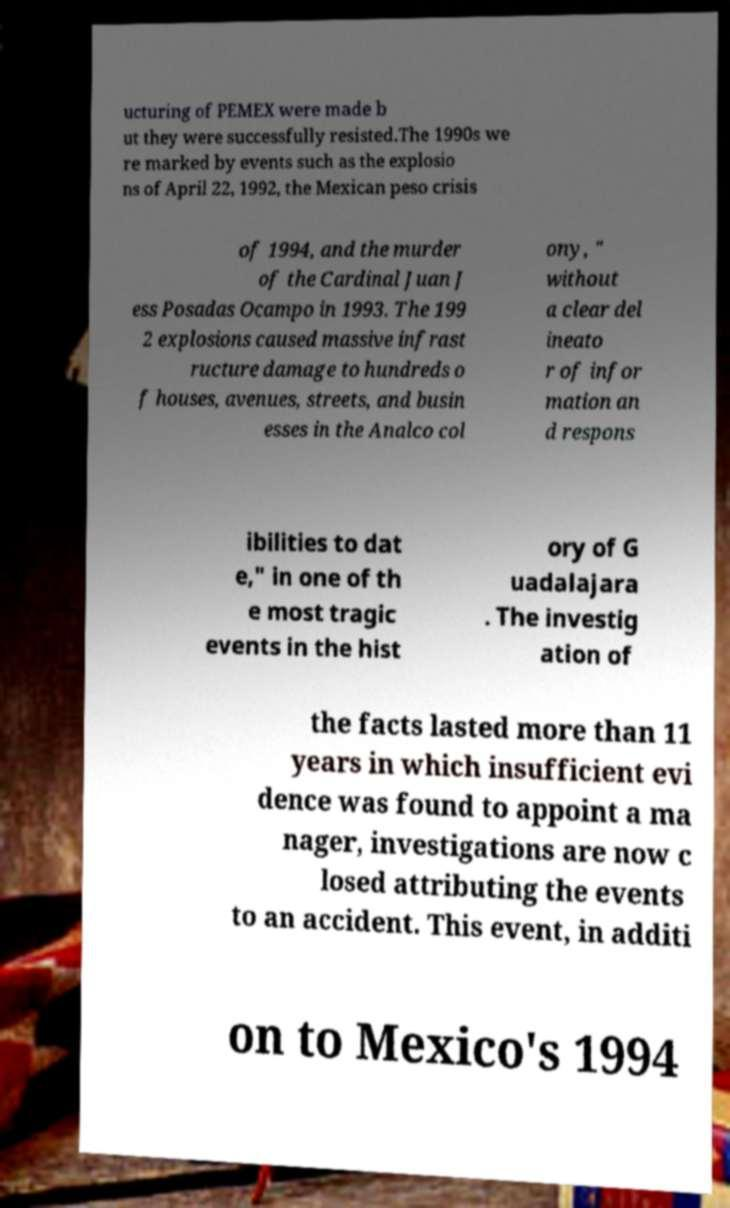There's text embedded in this image that I need extracted. Can you transcribe it verbatim? ucturing of PEMEX were made b ut they were successfully resisted.The 1990s we re marked by events such as the explosio ns of April 22, 1992, the Mexican peso crisis of 1994, and the murder of the Cardinal Juan J ess Posadas Ocampo in 1993. The 199 2 explosions caused massive infrast ructure damage to hundreds o f houses, avenues, streets, and busin esses in the Analco col ony, " without a clear del ineato r of infor mation an d respons ibilities to dat e," in one of th e most tragic events in the hist ory of G uadalajara . The investig ation of the facts lasted more than 11 years in which insufficient evi dence was found to appoint a ma nager, investigations are now c losed attributing the events to an accident. This event, in additi on to Mexico's 1994 